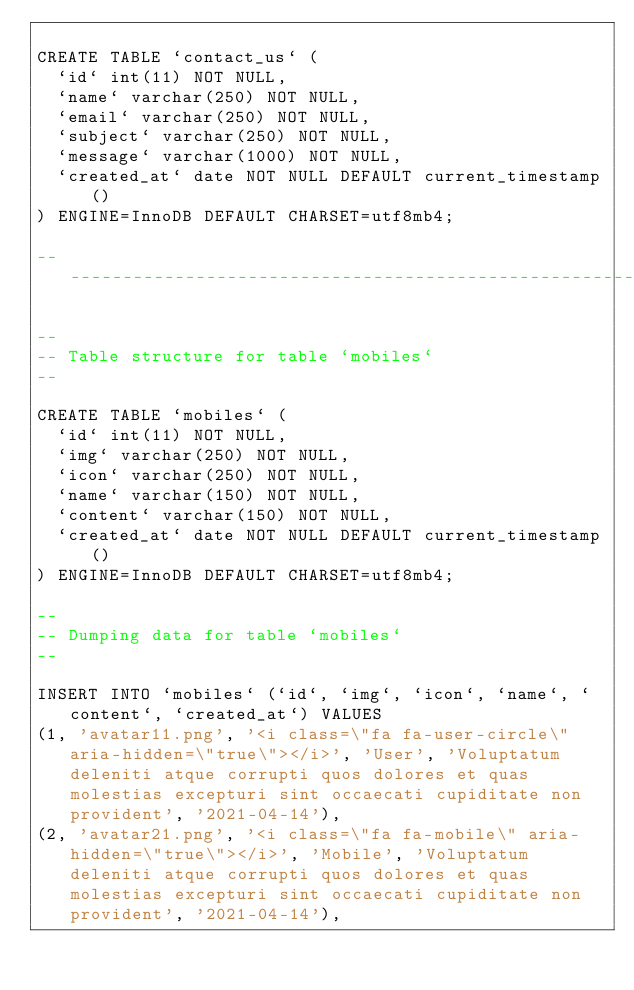Convert code to text. <code><loc_0><loc_0><loc_500><loc_500><_SQL_>
CREATE TABLE `contact_us` (
  `id` int(11) NOT NULL,
  `name` varchar(250) NOT NULL,
  `email` varchar(250) NOT NULL,
  `subject` varchar(250) NOT NULL,
  `message` varchar(1000) NOT NULL,
  `created_at` date NOT NULL DEFAULT current_timestamp()
) ENGINE=InnoDB DEFAULT CHARSET=utf8mb4;

-- --------------------------------------------------------

--
-- Table structure for table `mobiles`
--

CREATE TABLE `mobiles` (
  `id` int(11) NOT NULL,
  `img` varchar(250) NOT NULL,
  `icon` varchar(250) NOT NULL,
  `name` varchar(150) NOT NULL,
  `content` varchar(150) NOT NULL,
  `created_at` date NOT NULL DEFAULT current_timestamp()
) ENGINE=InnoDB DEFAULT CHARSET=utf8mb4;

--
-- Dumping data for table `mobiles`
--

INSERT INTO `mobiles` (`id`, `img`, `icon`, `name`, `content`, `created_at`) VALUES
(1, 'avatar11.png', '<i class=\"fa fa-user-circle\" aria-hidden=\"true\"></i>', 'User', 'Voluptatum deleniti atque corrupti quos dolores et quas molestias excepturi sint occaecati cupiditate non provident', '2021-04-14'),
(2, 'avatar21.png', '<i class=\"fa fa-mobile\" aria-hidden=\"true\"></i>', 'Mobile', 'Voluptatum deleniti atque corrupti quos dolores et quas molestias excepturi sint occaecati cupiditate non provident', '2021-04-14'),</code> 